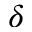<formula> <loc_0><loc_0><loc_500><loc_500>\delta</formula> 